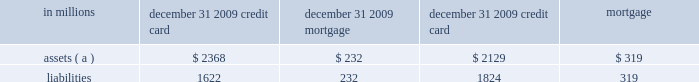Note 10 loan sales and securitizations loan sales we sell residential and commercial mortgage loans in loan securitization transactions sponsored by government national mortgage association ( gnma ) , fnma , and fhlmc and in certain instances to other third-party investors .
Gnma , fnma , and the fhlmc securitize our transferred loans into mortgage-backed securities for sale into the secondary market .
Generally , we do not retain any interest in the transferred loans other than mortgage servicing rights .
Refer to note 9 goodwill and other intangible assets for further discussion on our residential and commercial mortgage servicing rights assets .
During 2009 , residential and commercial mortgage loans sold totaled $ 19.8 billion and $ 5.7 billion , respectively .
During 2008 , commercial mortgage loans sold totaled $ 3.1 billion .
There were no residential mortgage loans sales in 2008 as these activities were obtained through our acquisition of national city .
Our continuing involvement in these loan sales consists primarily of servicing and limited repurchase obligations for loan and servicer breaches in representations and warranties .
Generally , we hold a cleanup call repurchase option for loans sold with servicing retained to the other third-party investors .
In certain circumstances as servicer , we advance principal and interest payments to the gses and other third-party investors and also may make collateral protection advances .
Our risk of loss in these servicing advances has historically been minimal .
We maintain a liability for estimated losses on loans expected to be repurchased as a result of breaches in loan and servicer representations and warranties .
We have also entered into recourse arrangements associated with commercial mortgage loans sold to fnma and fhlmc .
Refer to note 25 commitments and guarantees for further discussion on our repurchase liability and recourse arrangements .
Our maximum exposure to loss in our loan sale activities is limited to these repurchase and recourse obligations .
In addition , for certain loans transferred in the gnma and fnma transactions , we hold an option to repurchase individual delinquent loans that meet certain criteria .
Without prior authorization from these gses , this option gives pnc the ability to repurchase the delinquent loan at par .
Under gaap , once we have the unilateral ability to repurchase the delinquent loan , effective control over the loan has been regained and we are required to recognize the loan and a corresponding repurchase liability on the balance sheet regardless of our intent to repurchase the loan .
At december 31 , 2009 and december 31 , 2008 , the balance of our repurchase option asset and liability totaled $ 577 million and $ 476 million , respectively .
Securitizations in securitizations , loans are typically transferred to a qualifying special purpose entity ( qspe ) that is demonstrably distinct from the transferor to transfer the risk from our consolidated balance sheet .
A qspe is a bankruptcy-remote trust allowed to perform only certain passive activities .
In addition , these entities are self-liquidating and in certain instances are structured as real estate mortgage investment conduits ( remics ) for tax purposes .
The qspes are generally financed by issuing certificates for various levels of senior and subordinated tranches .
Qspes are exempt from consolidation provided certain conditions are met .
Our securitization activities were primarily obtained through our acquisition of national city .
Credit card receivables , automobile , and residential mortgage loans were securitized through qspes sponsored by ncb .
These qspes were financed primarily through the issuance and sale of beneficial interests to independent third parties and were not consolidated on our balance sheet at december 31 , 2009 or december 31 , 2008 .
However , see note 1 accounting policies regarding accounting guidance that impacts the accounting for these qspes effective january 1 , 2010 .
Qualitative and quantitative information about the securitization qspes and our retained interests in these transactions follow .
The following summarizes the assets and liabilities of the securitization qspes associated with securitization transactions that were outstanding at december 31 , 2009. .
( a ) represents period-end outstanding principal balances of loans transferred to the securitization qspes .
Credit card loans at december 31 , 2009 , the credit card securitization series 2005-1 , 2006-1 , 2007-1 , and 2008-3 were outstanding .
During the fourth quarter of 2009 , the 2008-1 and 2008-2 credit card securitization series matured .
Our continuing involvement in the securitized credit card receivables consists primarily of servicing and our holding of certain retained interests .
Servicing fees earned approximate current market rates for servicing fees ; therefore , no servicing asset or liability is recognized .
We hold a clean-up call repurchase option to the extent a securitization series extends past its scheduled note principal payoff date .
To the extent this occurs , the clean-up call option is triggered when the principal balance of the asset- backed notes of any series reaches 5% ( 5 % ) of the initial principal balance of the asset-backed notes issued at the securitization .
In 2009 what was the ratio of the credit cards assets to liabilities? 
Computations: (2368 / 1622)
Answer: 1.45993. 